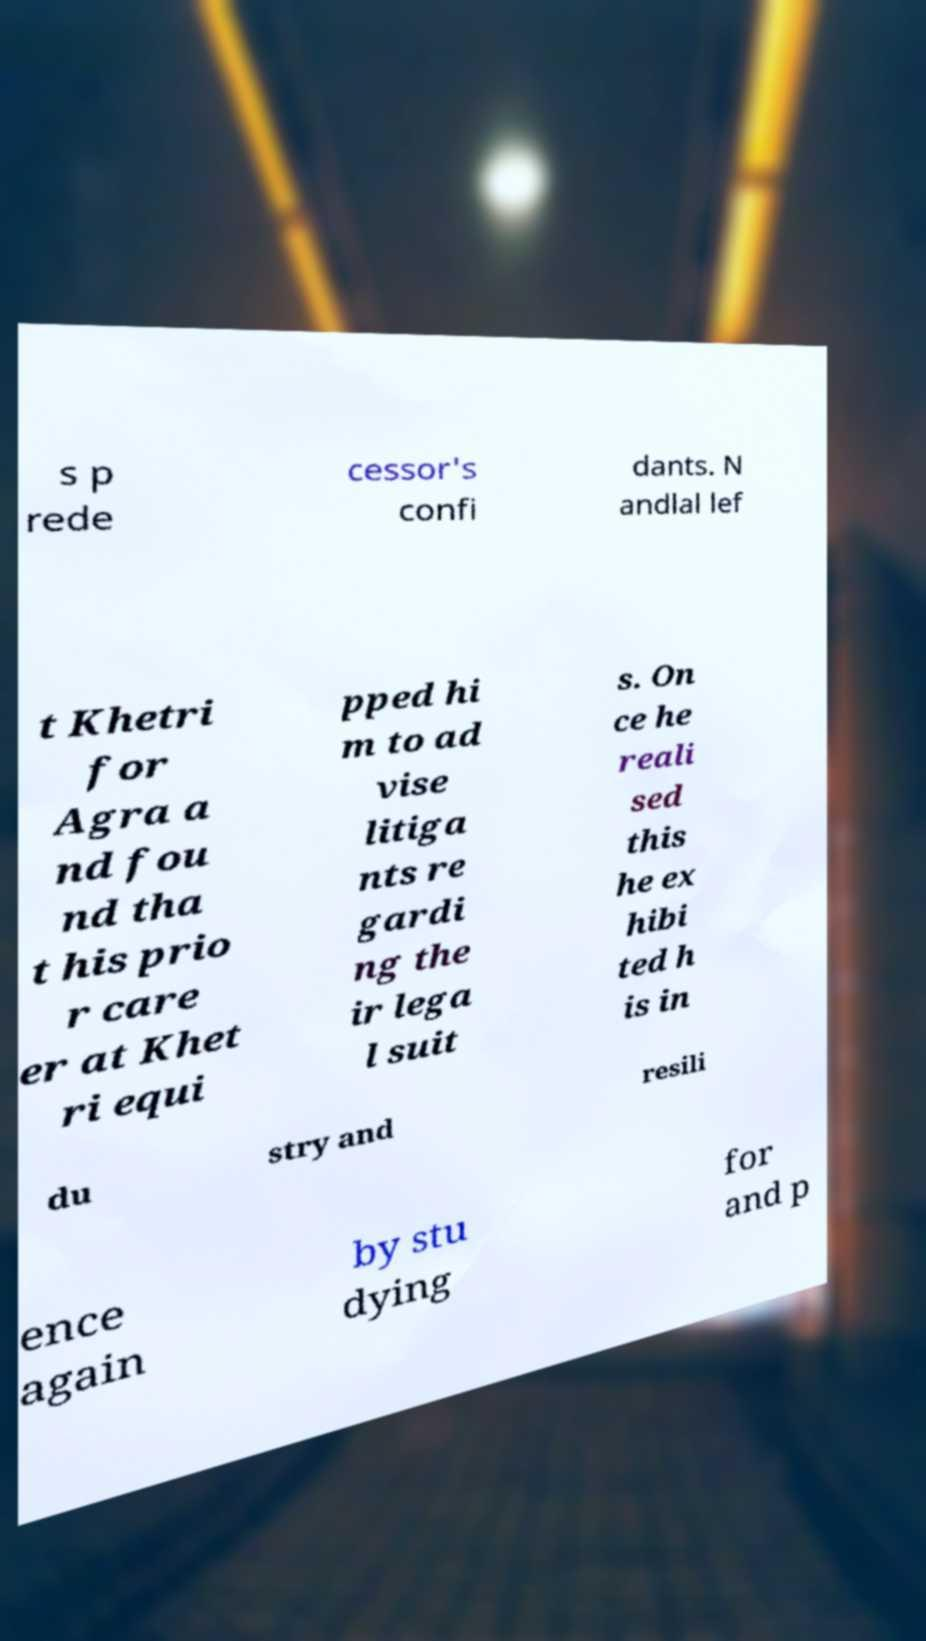There's text embedded in this image that I need extracted. Can you transcribe it verbatim? s p rede cessor's confi dants. N andlal lef t Khetri for Agra a nd fou nd tha t his prio r care er at Khet ri equi pped hi m to ad vise litiga nts re gardi ng the ir lega l suit s. On ce he reali sed this he ex hibi ted h is in du stry and resili ence again by stu dying for and p 